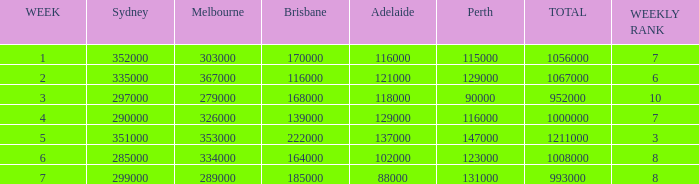How many Adelaide viewers were there in Week 5? 137000.0. 